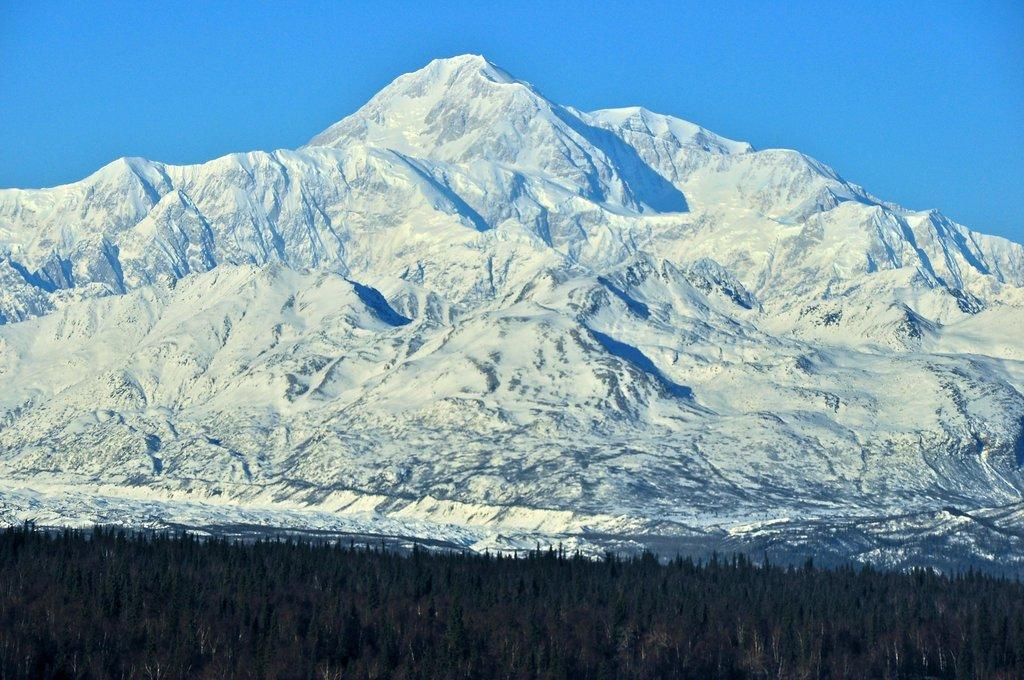What type of vegetation can be seen in the image? There are trees in the image. What type of geographical feature is visible in the image? There are snowy mountains in the image. What is visible in the background of the image? The sky is visible in the background of the image. What is the color of the sky in the image? The color of the sky is blue. What type of land is visible in the image? There is no specific type of land mentioned in the image; it only shows trees, snowy mountains, and a blue sky. What thrilling activity is being performed in the image? There is no thrilling activity being performed in the image; it is a still scene of nature. 